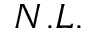Convert formula to latex. <formula><loc_0><loc_0><loc_500><loc_500>N . L .</formula> 